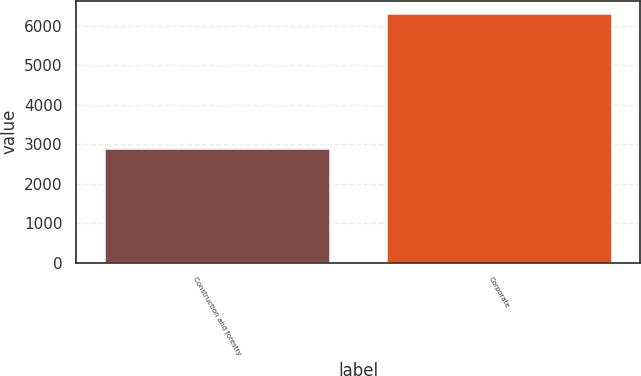Convert chart to OTSL. <chart><loc_0><loc_0><loc_500><loc_500><bar_chart><fcel>Construction and forestry<fcel>Corporate<nl><fcel>2915<fcel>6319<nl></chart> 